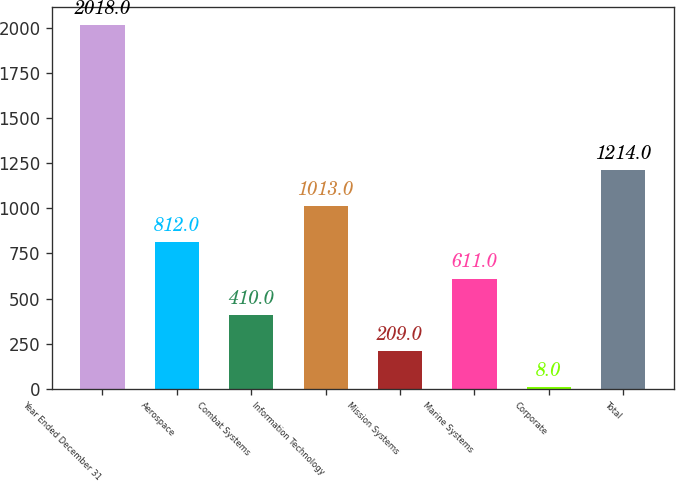<chart> <loc_0><loc_0><loc_500><loc_500><bar_chart><fcel>Year Ended December 31<fcel>Aerospace<fcel>Combat Systems<fcel>Information Technology<fcel>Mission Systems<fcel>Marine Systems<fcel>Corporate<fcel>Total<nl><fcel>2018<fcel>812<fcel>410<fcel>1013<fcel>209<fcel>611<fcel>8<fcel>1214<nl></chart> 